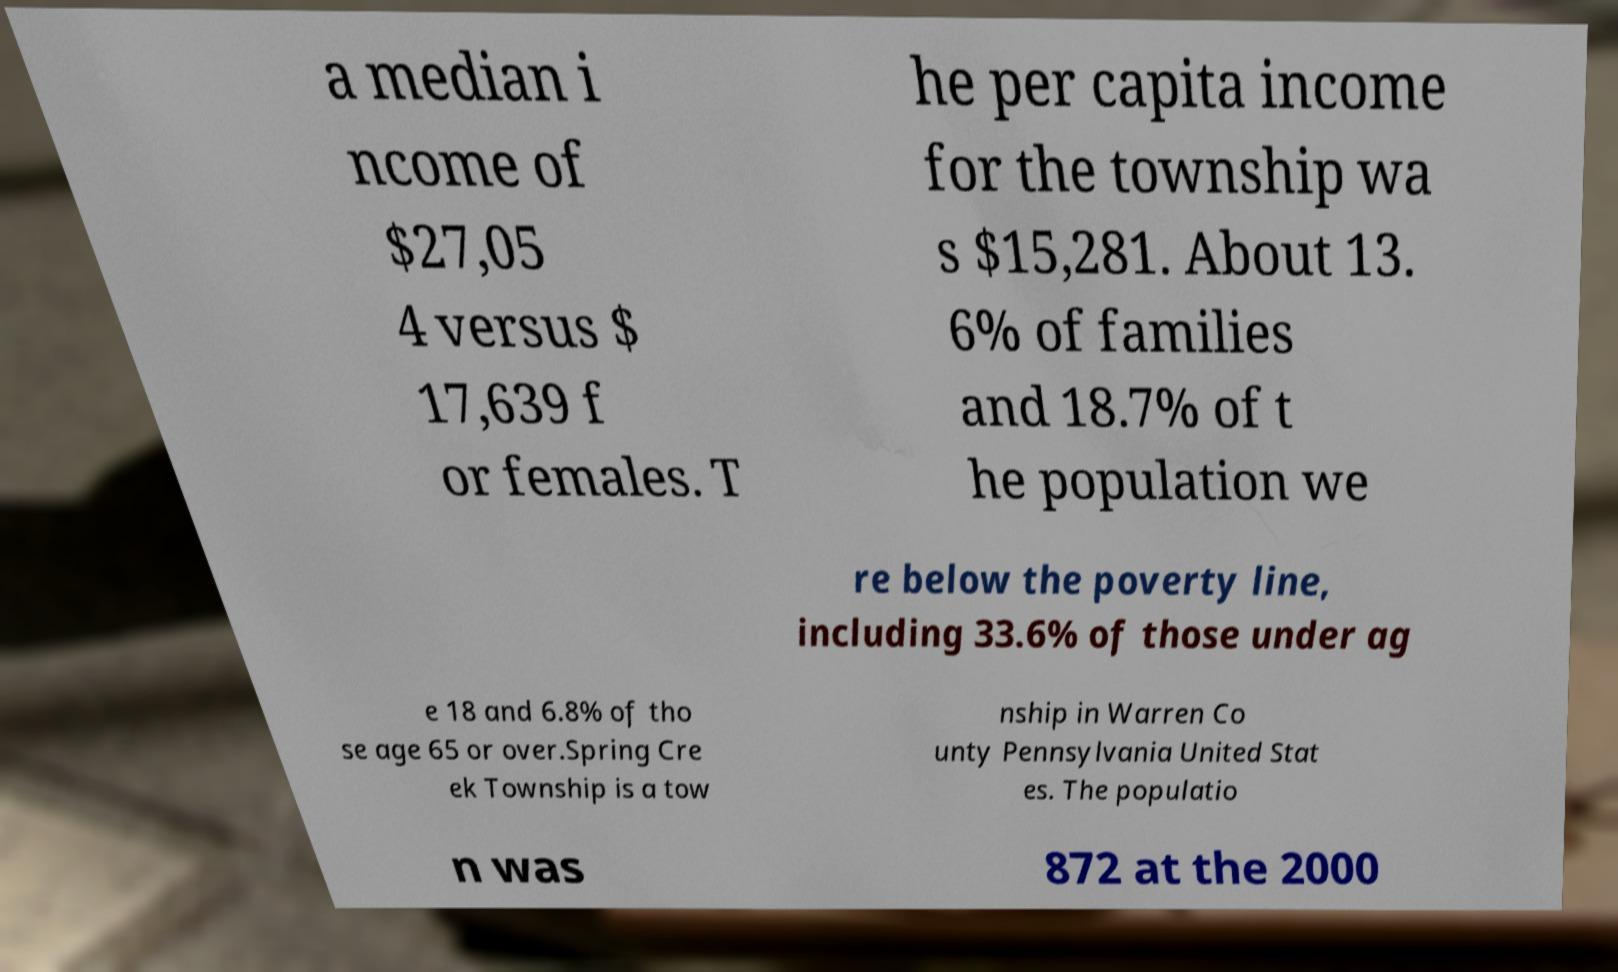For documentation purposes, I need the text within this image transcribed. Could you provide that? a median i ncome of $27,05 4 versus $ 17,639 f or females. T he per capita income for the township wa s $15,281. About 13. 6% of families and 18.7% of t he population we re below the poverty line, including 33.6% of those under ag e 18 and 6.8% of tho se age 65 or over.Spring Cre ek Township is a tow nship in Warren Co unty Pennsylvania United Stat es. The populatio n was 872 at the 2000 